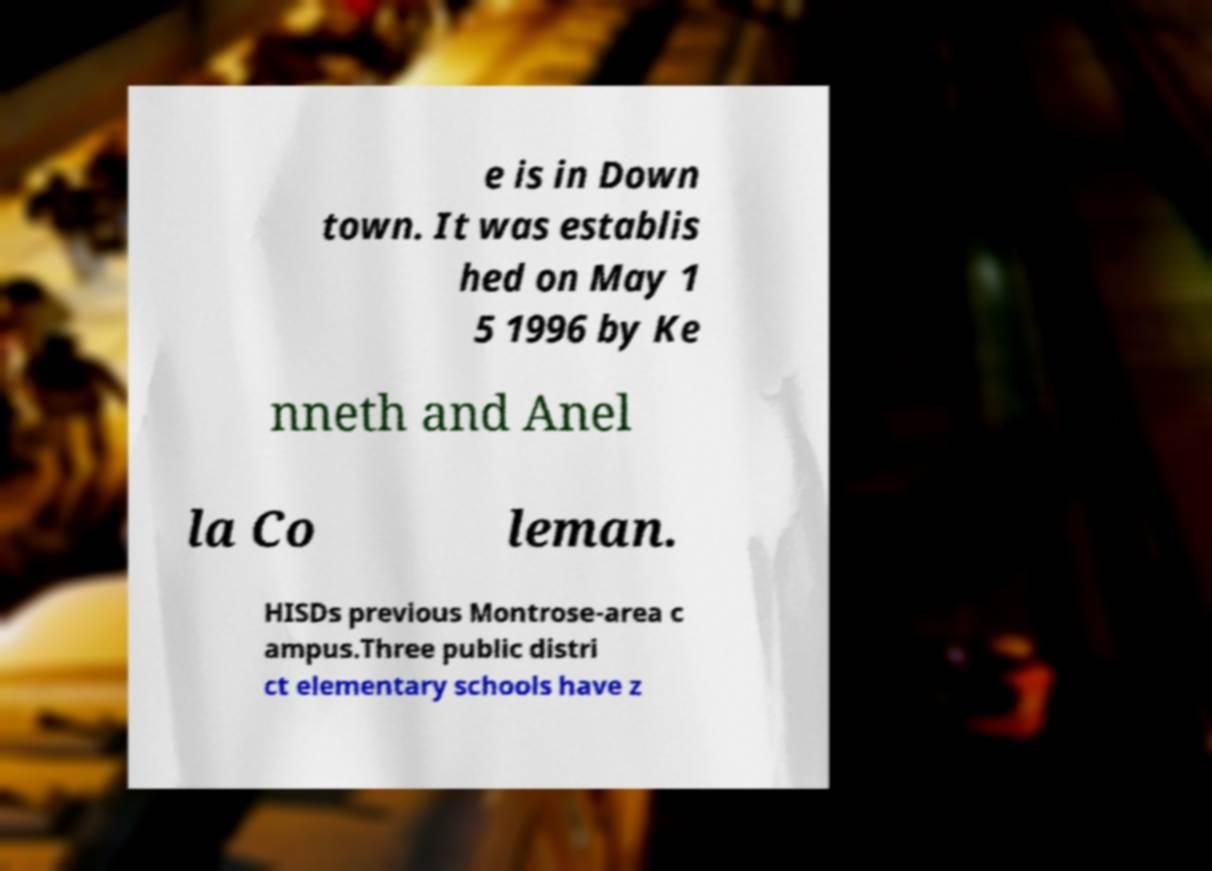What messages or text are displayed in this image? I need them in a readable, typed format. e is in Down town. It was establis hed on May 1 5 1996 by Ke nneth and Anel la Co leman. HISDs previous Montrose-area c ampus.Three public distri ct elementary schools have z 